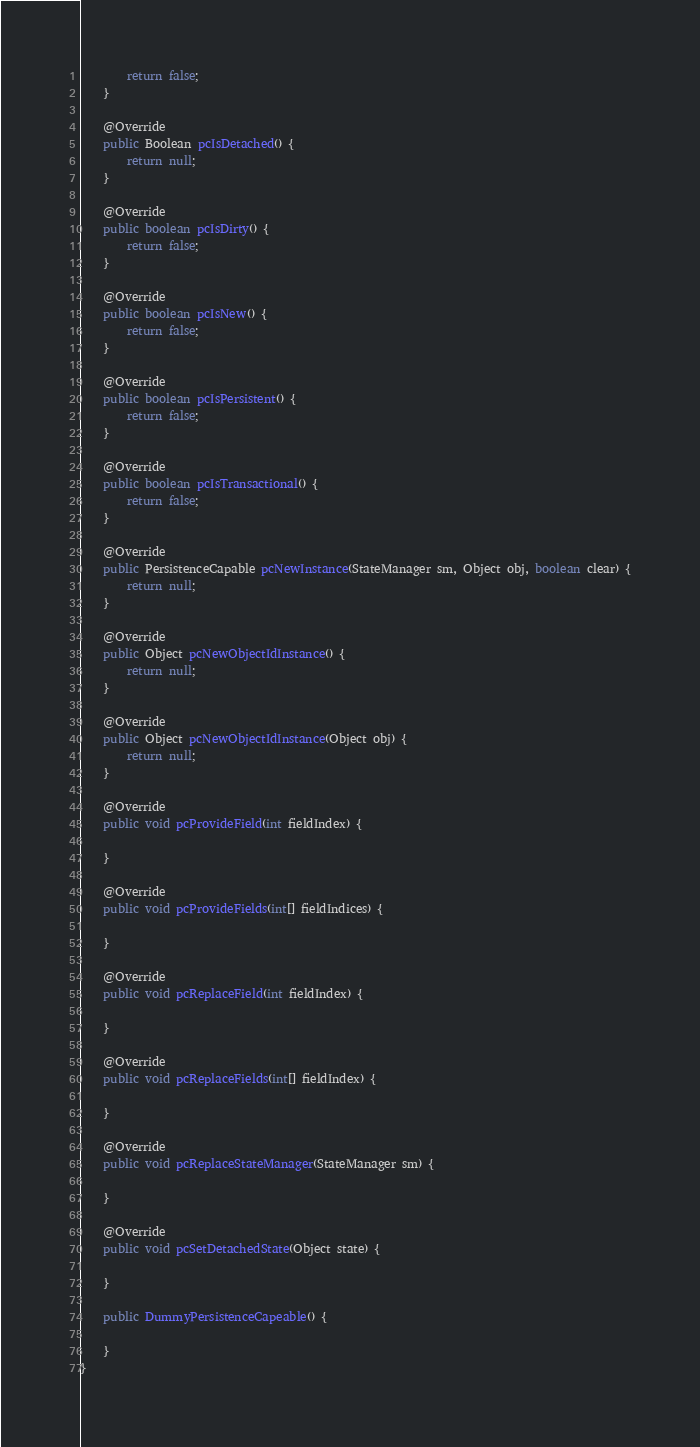Convert code to text. <code><loc_0><loc_0><loc_500><loc_500><_Java_>        return false;
    }

    @Override
    public Boolean pcIsDetached() {
        return null;
    }

    @Override
    public boolean pcIsDirty() {
        return false;
    }

    @Override
    public boolean pcIsNew() {
        return false;
    }

    @Override
    public boolean pcIsPersistent() {
        return false;
    }

    @Override
    public boolean pcIsTransactional() {
        return false;
    }

    @Override
    public PersistenceCapable pcNewInstance(StateManager sm, Object obj, boolean clear) {
        return null;
    }

    @Override
    public Object pcNewObjectIdInstance() {
        return null;
    }

    @Override
    public Object pcNewObjectIdInstance(Object obj) {
        return null;
    }

    @Override
    public void pcProvideField(int fieldIndex) {

    }

    @Override
    public void pcProvideFields(int[] fieldIndices) {

    }

    @Override
    public void pcReplaceField(int fieldIndex) {

    }

    @Override
    public void pcReplaceFields(int[] fieldIndex) {

    }

    @Override
    public void pcReplaceStateManager(StateManager sm) {

    }

    @Override
    public void pcSetDetachedState(Object state) {

    }

    public DummyPersistenceCapeable() {

    }
}
</code> 